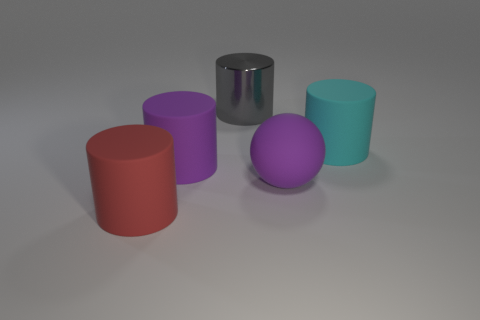Can you tell me how many objects are there and describe their colors and shapes? Certainly! In the image, there are five objects. Starting from the left, there is a red cylinder, a purple cylinder, a silver cylinder with a reflective surface, a purple ball with a matte finish, and a teal cylinder. 